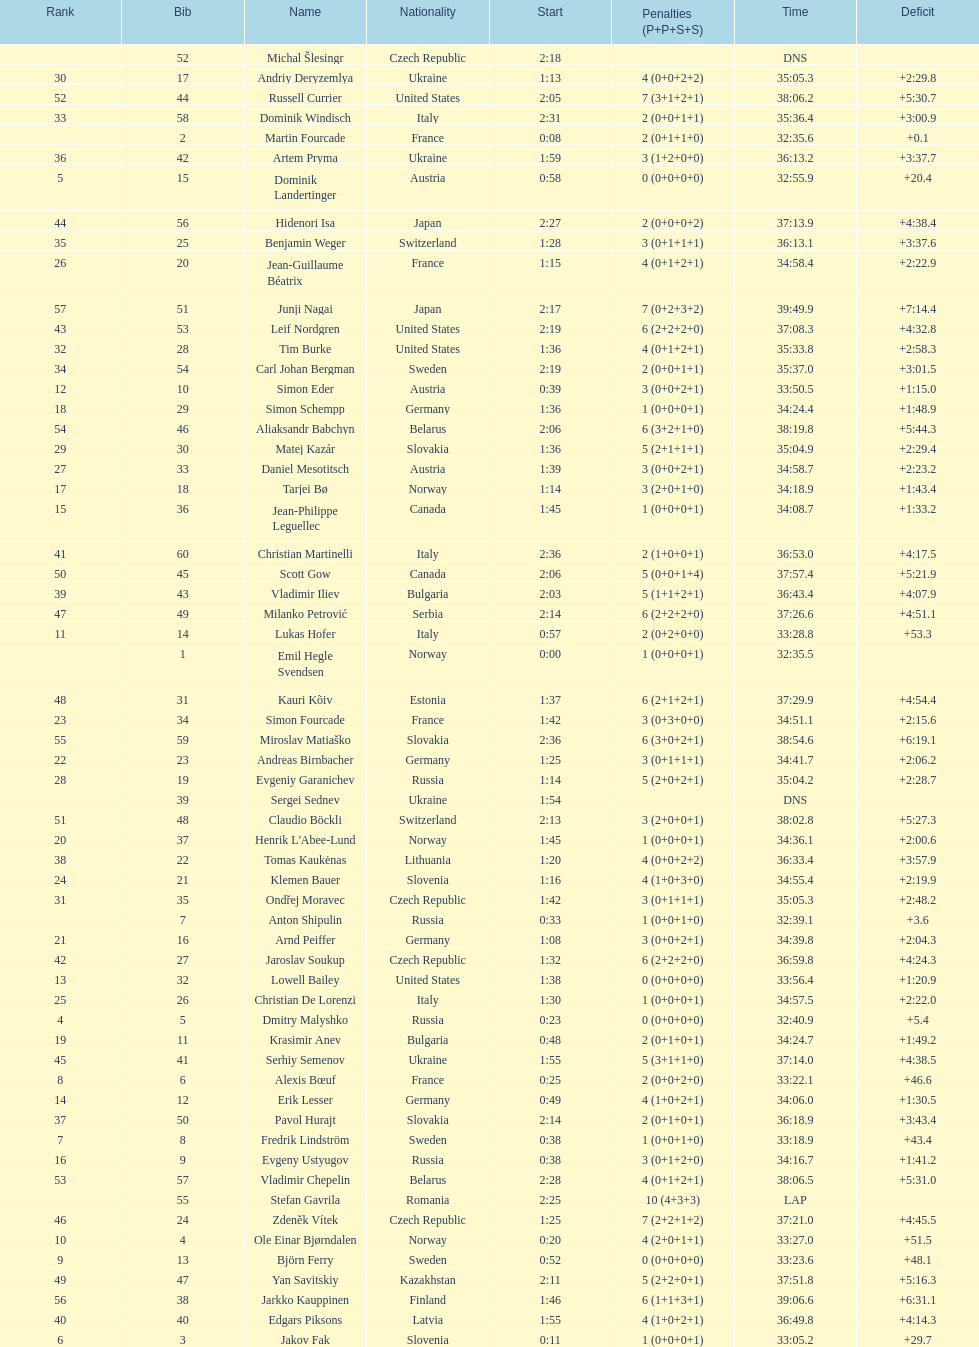Would you be able to parse every entry in this table? {'header': ['Rank', 'Bib', 'Name', 'Nationality', 'Start', 'Penalties (P+P+S+S)', 'Time', 'Deficit'], 'rows': [['', '52', 'Michal Šlesingr', 'Czech Republic', '2:18', '', 'DNS', ''], ['30', '17', 'Andriy Deryzemlya', 'Ukraine', '1:13', '4 (0+0+2+2)', '35:05.3', '+2:29.8'], ['52', '44', 'Russell Currier', 'United States', '2:05', '7 (3+1+2+1)', '38:06.2', '+5:30.7'], ['33', '58', 'Dominik Windisch', 'Italy', '2:31', '2 (0+0+1+1)', '35:36.4', '+3:00.9'], ['', '2', 'Martin Fourcade', 'France', '0:08', '2 (0+1+1+0)', '32:35.6', '+0.1'], ['36', '42', 'Artem Pryma', 'Ukraine', '1:59', '3 (1+2+0+0)', '36:13.2', '+3:37.7'], ['5', '15', 'Dominik Landertinger', 'Austria', '0:58', '0 (0+0+0+0)', '32:55.9', '+20.4'], ['44', '56', 'Hidenori Isa', 'Japan', '2:27', '2 (0+0+0+2)', '37:13.9', '+4:38.4'], ['35', '25', 'Benjamin Weger', 'Switzerland', '1:28', '3 (0+1+1+1)', '36:13.1', '+3:37.6'], ['26', '20', 'Jean-Guillaume Béatrix', 'France', '1:15', '4 (0+1+2+1)', '34:58.4', '+2:22.9'], ['57', '51', 'Junji Nagai', 'Japan', '2:17', '7 (0+2+3+2)', '39:49.9', '+7:14.4'], ['43', '53', 'Leif Nordgren', 'United States', '2:19', '6 (2+2+2+0)', '37:08.3', '+4:32.8'], ['32', '28', 'Tim Burke', 'United States', '1:36', '4 (0+1+2+1)', '35:33.8', '+2:58.3'], ['34', '54', 'Carl Johan Bergman', 'Sweden', '2:19', '2 (0+0+1+1)', '35:37.0', '+3:01.5'], ['12', '10', 'Simon Eder', 'Austria', '0:39', '3 (0+0+2+1)', '33:50.5', '+1:15.0'], ['18', '29', 'Simon Schempp', 'Germany', '1:36', '1 (0+0+0+1)', '34:24.4', '+1:48.9'], ['54', '46', 'Aliaksandr Babchyn', 'Belarus', '2:06', '6 (3+2+1+0)', '38:19.8', '+5:44.3'], ['29', '30', 'Matej Kazár', 'Slovakia', '1:36', '5 (2+1+1+1)', '35:04.9', '+2:29.4'], ['27', '33', 'Daniel Mesotitsch', 'Austria', '1:39', '3 (0+0+2+1)', '34:58.7', '+2:23.2'], ['17', '18', 'Tarjei Bø', 'Norway', '1:14', '3 (2+0+1+0)', '34:18.9', '+1:43.4'], ['15', '36', 'Jean-Philippe Leguellec', 'Canada', '1:45', '1 (0+0+0+1)', '34:08.7', '+1:33.2'], ['41', '60', 'Christian Martinelli', 'Italy', '2:36', '2 (1+0+0+1)', '36:53.0', '+4:17.5'], ['50', '45', 'Scott Gow', 'Canada', '2:06', '5 (0+0+1+4)', '37:57.4', '+5:21.9'], ['39', '43', 'Vladimir Iliev', 'Bulgaria', '2:03', '5 (1+1+2+1)', '36:43.4', '+4:07.9'], ['47', '49', 'Milanko Petrović', 'Serbia', '2:14', '6 (2+2+2+0)', '37:26.6', '+4:51.1'], ['11', '14', 'Lukas Hofer', 'Italy', '0:57', '2 (0+2+0+0)', '33:28.8', '+53.3'], ['', '1', 'Emil Hegle Svendsen', 'Norway', '0:00', '1 (0+0+0+1)', '32:35.5', ''], ['48', '31', 'Kauri Kõiv', 'Estonia', '1:37', '6 (2+1+2+1)', '37:29.9', '+4:54.4'], ['23', '34', 'Simon Fourcade', 'France', '1:42', '3 (0+3+0+0)', '34:51.1', '+2:15.6'], ['55', '59', 'Miroslav Matiaško', 'Slovakia', '2:36', '6 (3+0+2+1)', '38:54.6', '+6:19.1'], ['22', '23', 'Andreas Birnbacher', 'Germany', '1:25', '3 (0+1+1+1)', '34:41.7', '+2:06.2'], ['28', '19', 'Evgeniy Garanichev', 'Russia', '1:14', '5 (2+0+2+1)', '35:04.2', '+2:28.7'], ['', '39', 'Sergei Sednev', 'Ukraine', '1:54', '', 'DNS', ''], ['51', '48', 'Claudio Böckli', 'Switzerland', '2:13', '3 (2+0+0+1)', '38:02.8', '+5:27.3'], ['20', '37', "Henrik L'Abee-Lund", 'Norway', '1:45', '1 (0+0+0+1)', '34:36.1', '+2:00.6'], ['38', '22', 'Tomas Kaukėnas', 'Lithuania', '1:20', '4 (0+0+2+2)', '36:33.4', '+3:57.9'], ['24', '21', 'Klemen Bauer', 'Slovenia', '1:16', '4 (1+0+3+0)', '34:55.4', '+2:19.9'], ['31', '35', 'Ondřej Moravec', 'Czech Republic', '1:42', '3 (0+1+1+1)', '35:05.3', '+2:48.2'], ['', '7', 'Anton Shipulin', 'Russia', '0:33', '1 (0+0+1+0)', '32:39.1', '+3.6'], ['21', '16', 'Arnd Peiffer', 'Germany', '1:08', '3 (0+0+2+1)', '34:39.8', '+2:04.3'], ['42', '27', 'Jaroslav Soukup', 'Czech Republic', '1:32', '6 (2+2+2+0)', '36:59.8', '+4:24.3'], ['13', '32', 'Lowell Bailey', 'United States', '1:38', '0 (0+0+0+0)', '33:56.4', '+1:20.9'], ['25', '26', 'Christian De Lorenzi', 'Italy', '1:30', '1 (0+0+0+1)', '34:57.5', '+2:22.0'], ['4', '5', 'Dmitry Malyshko', 'Russia', '0:23', '0 (0+0+0+0)', '32:40.9', '+5.4'], ['19', '11', 'Krasimir Anev', 'Bulgaria', '0:48', '2 (0+1+0+1)', '34:24.7', '+1:49.2'], ['45', '41', 'Serhiy Semenov', 'Ukraine', '1:55', '5 (3+1+1+0)', '37:14.0', '+4:38.5'], ['8', '6', 'Alexis Bœuf', 'France', '0:25', '2 (0+0+2+0)', '33:22.1', '+46.6'], ['14', '12', 'Erik Lesser', 'Germany', '0:49', '4 (1+0+2+1)', '34:06.0', '+1:30.5'], ['37', '50', 'Pavol Hurajt', 'Slovakia', '2:14', '2 (0+1+0+1)', '36:18.9', '+3:43.4'], ['7', '8', 'Fredrik Lindström', 'Sweden', '0:38', '1 (0+0+1+0)', '33:18.9', '+43.4'], ['16', '9', 'Evgeny Ustyugov', 'Russia', '0:38', '3 (0+1+2+0)', '34:16.7', '+1:41.2'], ['53', '57', 'Vladimir Chepelin', 'Belarus', '2:28', '4 (0+1+2+1)', '38:06.5', '+5:31.0'], ['', '55', 'Stefan Gavrila', 'Romania', '2:25', '10 (4+3+3)', 'LAP', ''], ['46', '24', 'Zdeněk Vítek', 'Czech Republic', '1:25', '7 (2+2+1+2)', '37:21.0', '+4:45.5'], ['10', '4', 'Ole Einar Bjørndalen', 'Norway', '0:20', '4 (2+0+1+1)', '33:27.0', '+51.5'], ['9', '13', 'Björn Ferry', 'Sweden', '0:52', '0 (0+0+0+0)', '33:23.6', '+48.1'], ['49', '47', 'Yan Savitskiy', 'Kazakhstan', '2:11', '5 (2+2+0+1)', '37:51.8', '+5:16.3'], ['56', '38', 'Jarkko Kauppinen', 'Finland', '1:46', '6 (1+1+3+1)', '39:06.6', '+6:31.1'], ['40', '40', 'Edgars Piksons', 'Latvia', '1:55', '4 (1+0+2+1)', '36:49.8', '+4:14.3'], ['6', '3', 'Jakov Fak', 'Slovenia', '0:11', '1 (0+0+0+1)', '33:05.2', '+29.7']]} How many took at least 35:00 to finish? 30. 